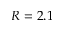Convert formula to latex. <formula><loc_0><loc_0><loc_500><loc_500>R = 2 . 1</formula> 